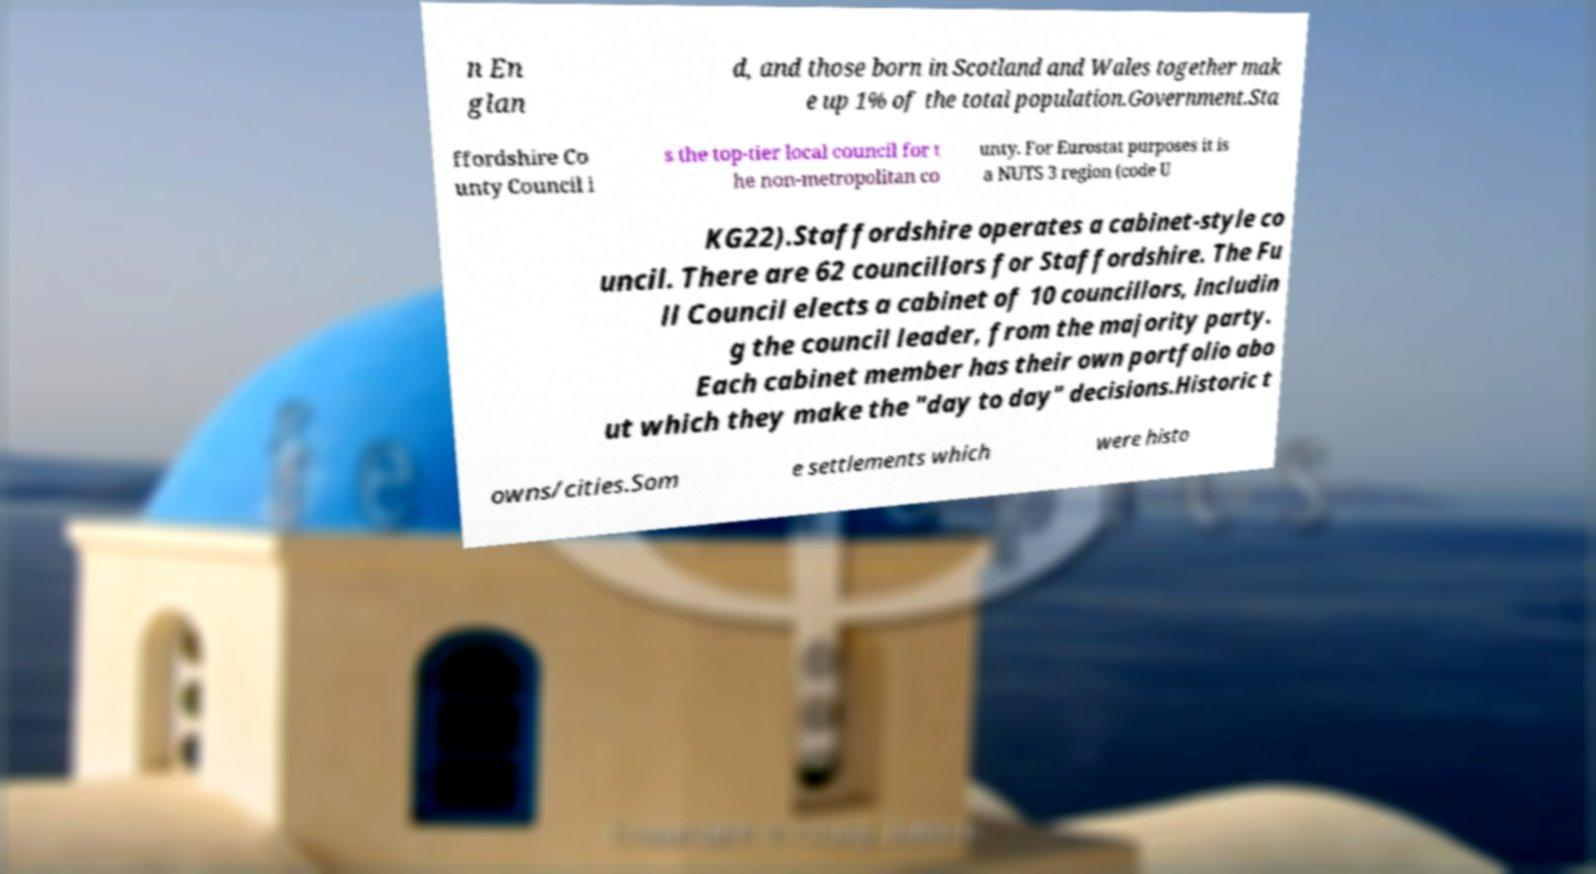Please identify and transcribe the text found in this image. n En glan d, and those born in Scotland and Wales together mak e up 1% of the total population.Government.Sta ffordshire Co unty Council i s the top-tier local council for t he non-metropolitan co unty. For Eurostat purposes it is a NUTS 3 region (code U KG22).Staffordshire operates a cabinet-style co uncil. There are 62 councillors for Staffordshire. The Fu ll Council elects a cabinet of 10 councillors, includin g the council leader, from the majority party. Each cabinet member has their own portfolio abo ut which they make the "day to day" decisions.Historic t owns/cities.Som e settlements which were histo 